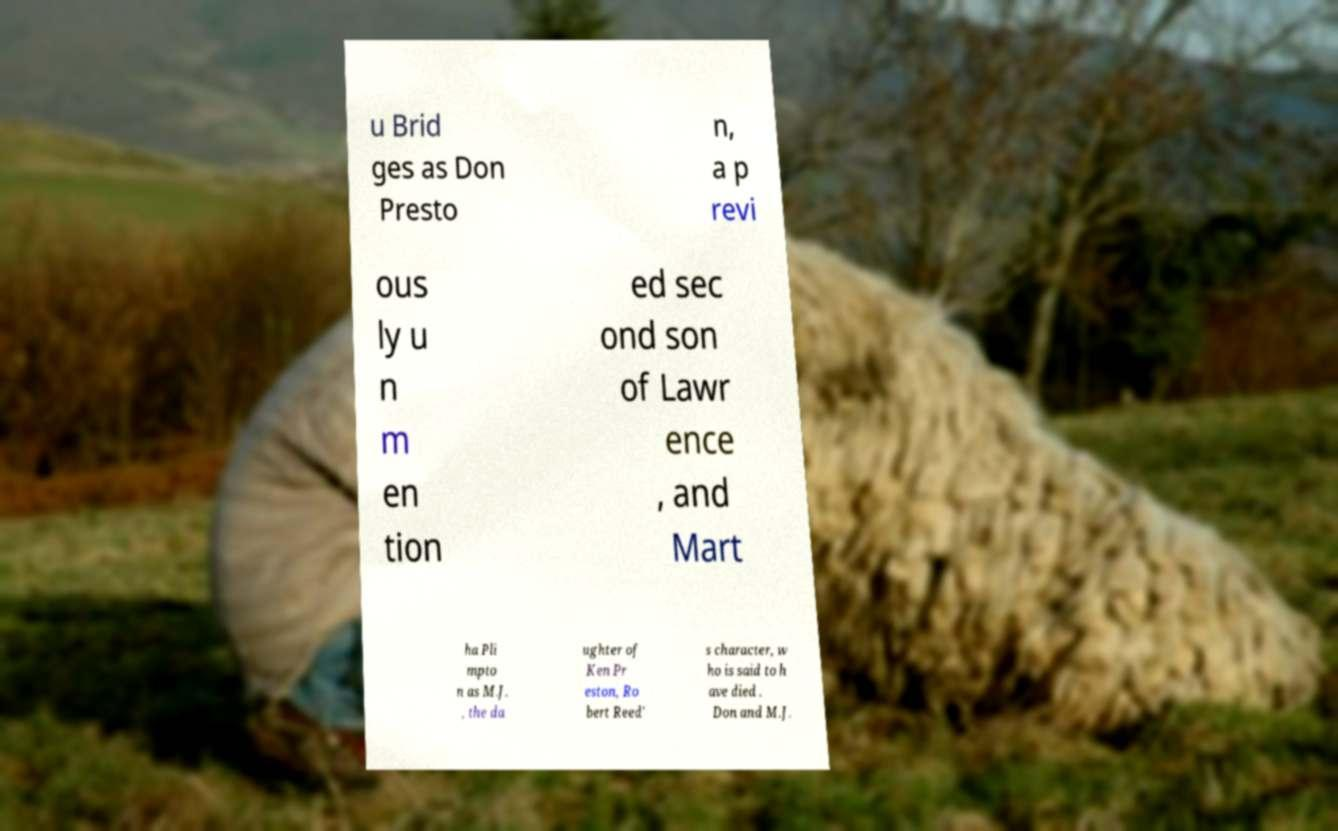Can you accurately transcribe the text from the provided image for me? u Brid ges as Don Presto n, a p revi ous ly u n m en tion ed sec ond son of Lawr ence , and Mart ha Pli mpto n as M.J. , the da ughter of Ken Pr eston, Ro bert Reed' s character, w ho is said to h ave died . Don and M.J. 